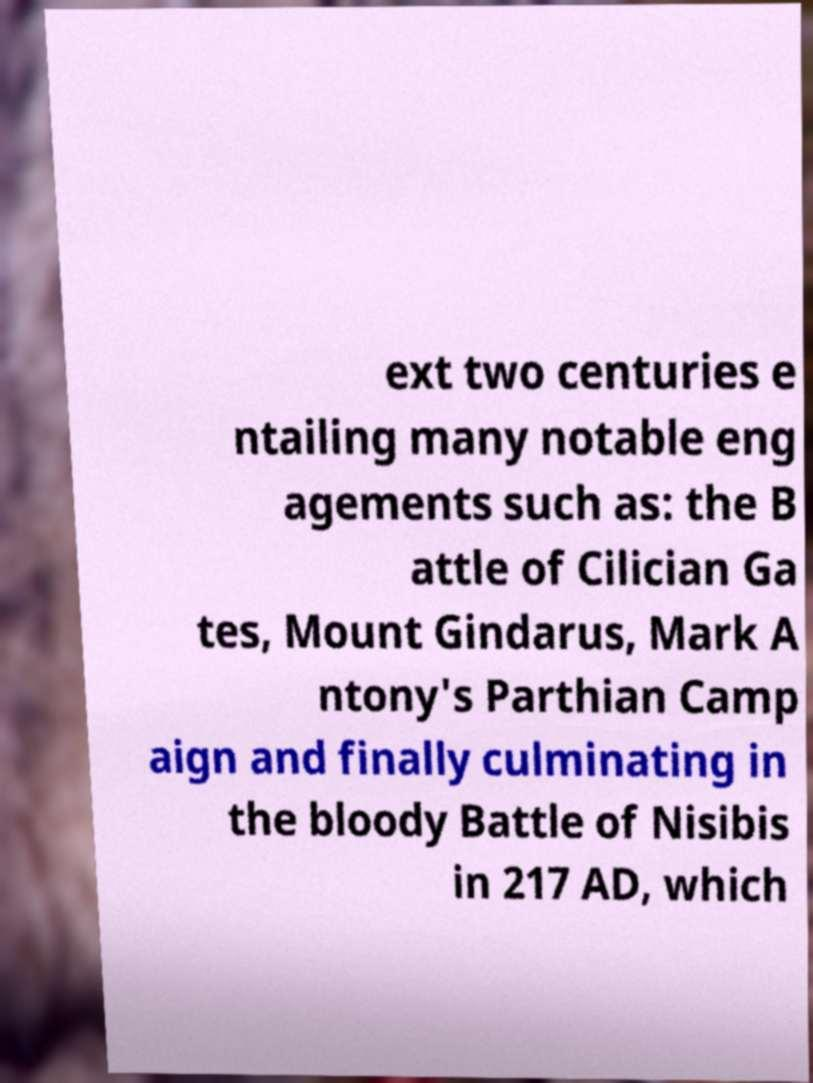Please read and relay the text visible in this image. What does it say? ext two centuries e ntailing many notable eng agements such as: the B attle of Cilician Ga tes, Mount Gindarus, Mark A ntony's Parthian Camp aign and finally culminating in the bloody Battle of Nisibis in 217 AD, which 